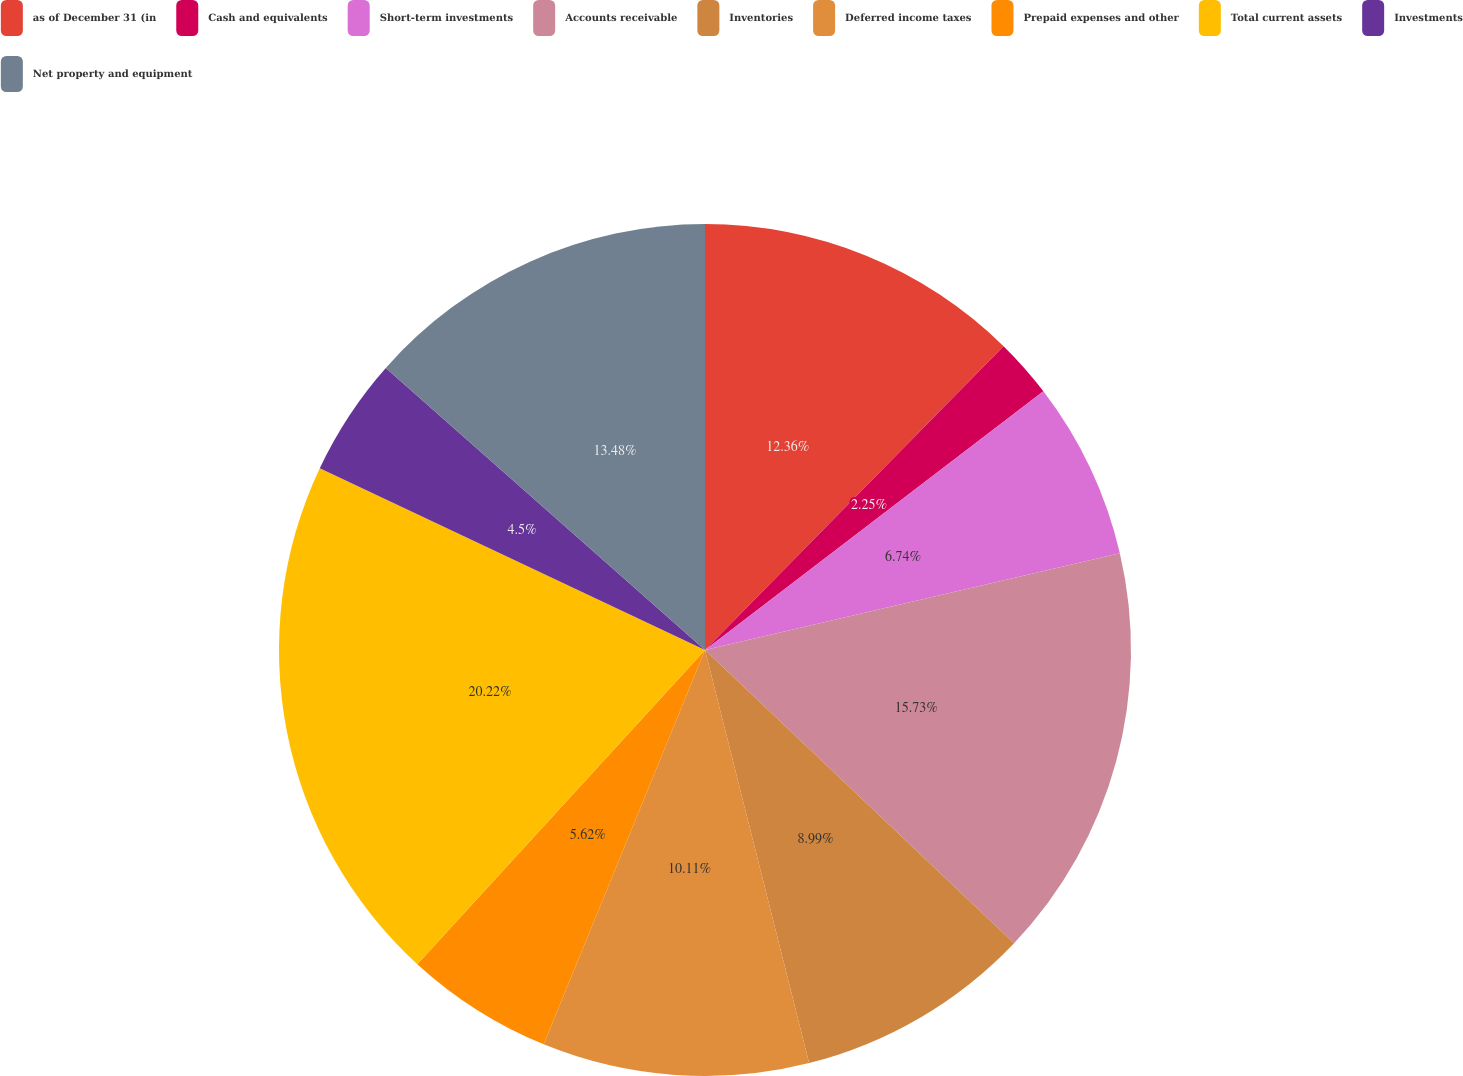Convert chart. <chart><loc_0><loc_0><loc_500><loc_500><pie_chart><fcel>as of December 31 (in<fcel>Cash and equivalents<fcel>Short-term investments<fcel>Accounts receivable<fcel>Inventories<fcel>Deferred income taxes<fcel>Prepaid expenses and other<fcel>Total current assets<fcel>Investments<fcel>Net property and equipment<nl><fcel>12.36%<fcel>2.25%<fcel>6.74%<fcel>15.73%<fcel>8.99%<fcel>10.11%<fcel>5.62%<fcel>20.22%<fcel>4.5%<fcel>13.48%<nl></chart> 